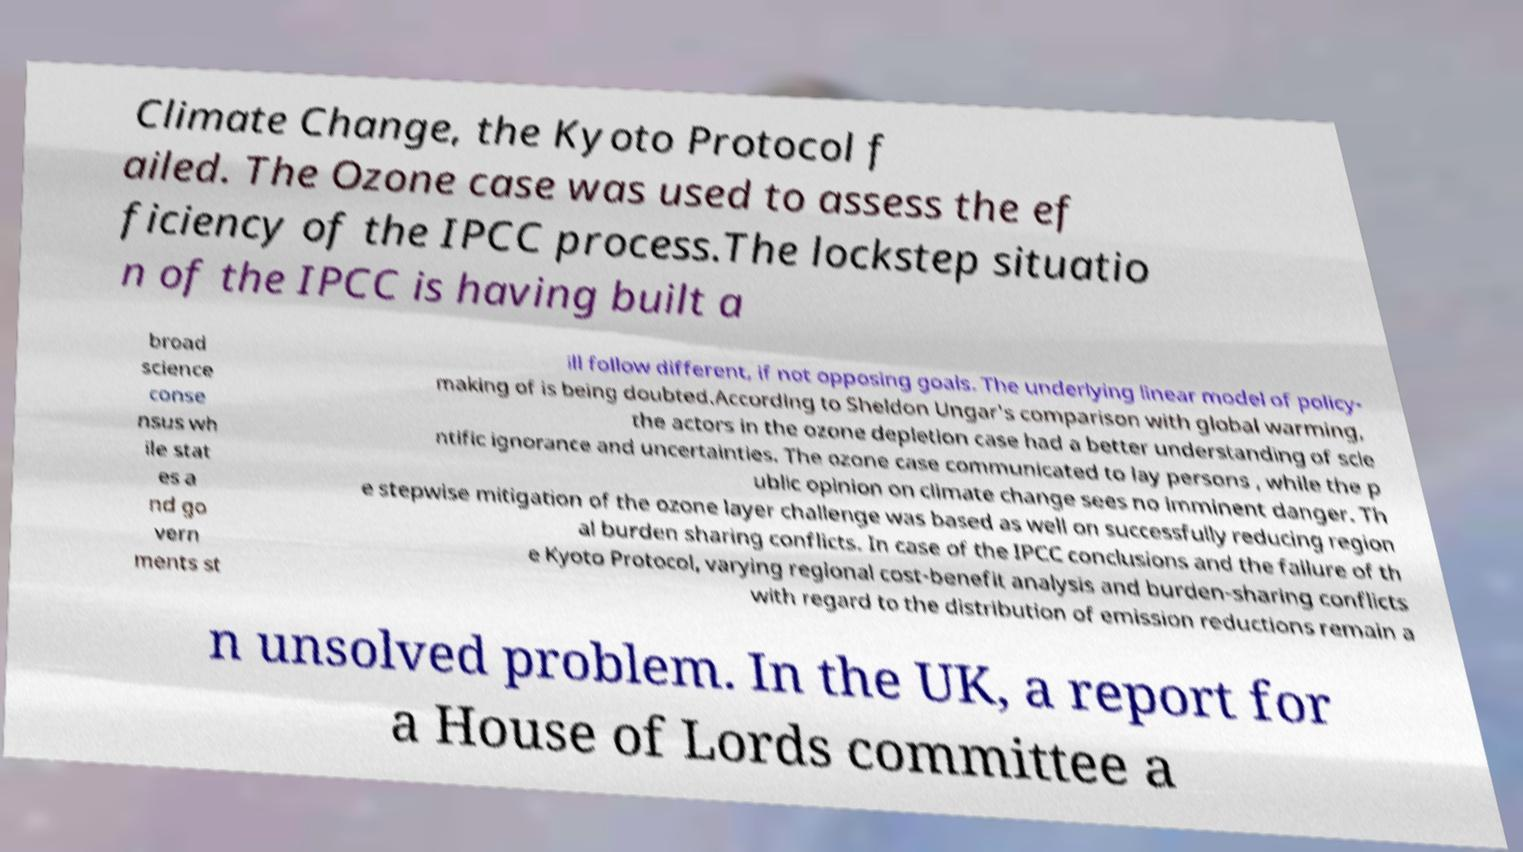What messages or text are displayed in this image? I need them in a readable, typed format. Climate Change, the Kyoto Protocol f ailed. The Ozone case was used to assess the ef ficiency of the IPCC process.The lockstep situatio n of the IPCC is having built a broad science conse nsus wh ile stat es a nd go vern ments st ill follow different, if not opposing goals. The underlying linear model of policy- making of is being doubted.According to Sheldon Ungar's comparison with global warming, the actors in the ozone depletion case had a better understanding of scie ntific ignorance and uncertainties. The ozone case communicated to lay persons , while the p ublic opinion on climate change sees no imminent danger. Th e stepwise mitigation of the ozone layer challenge was based as well on successfully reducing region al burden sharing conflicts. In case of the IPCC conclusions and the failure of th e Kyoto Protocol, varying regional cost-benefit analysis and burden-sharing conflicts with regard to the distribution of emission reductions remain a n unsolved problem. In the UK, a report for a House of Lords committee a 